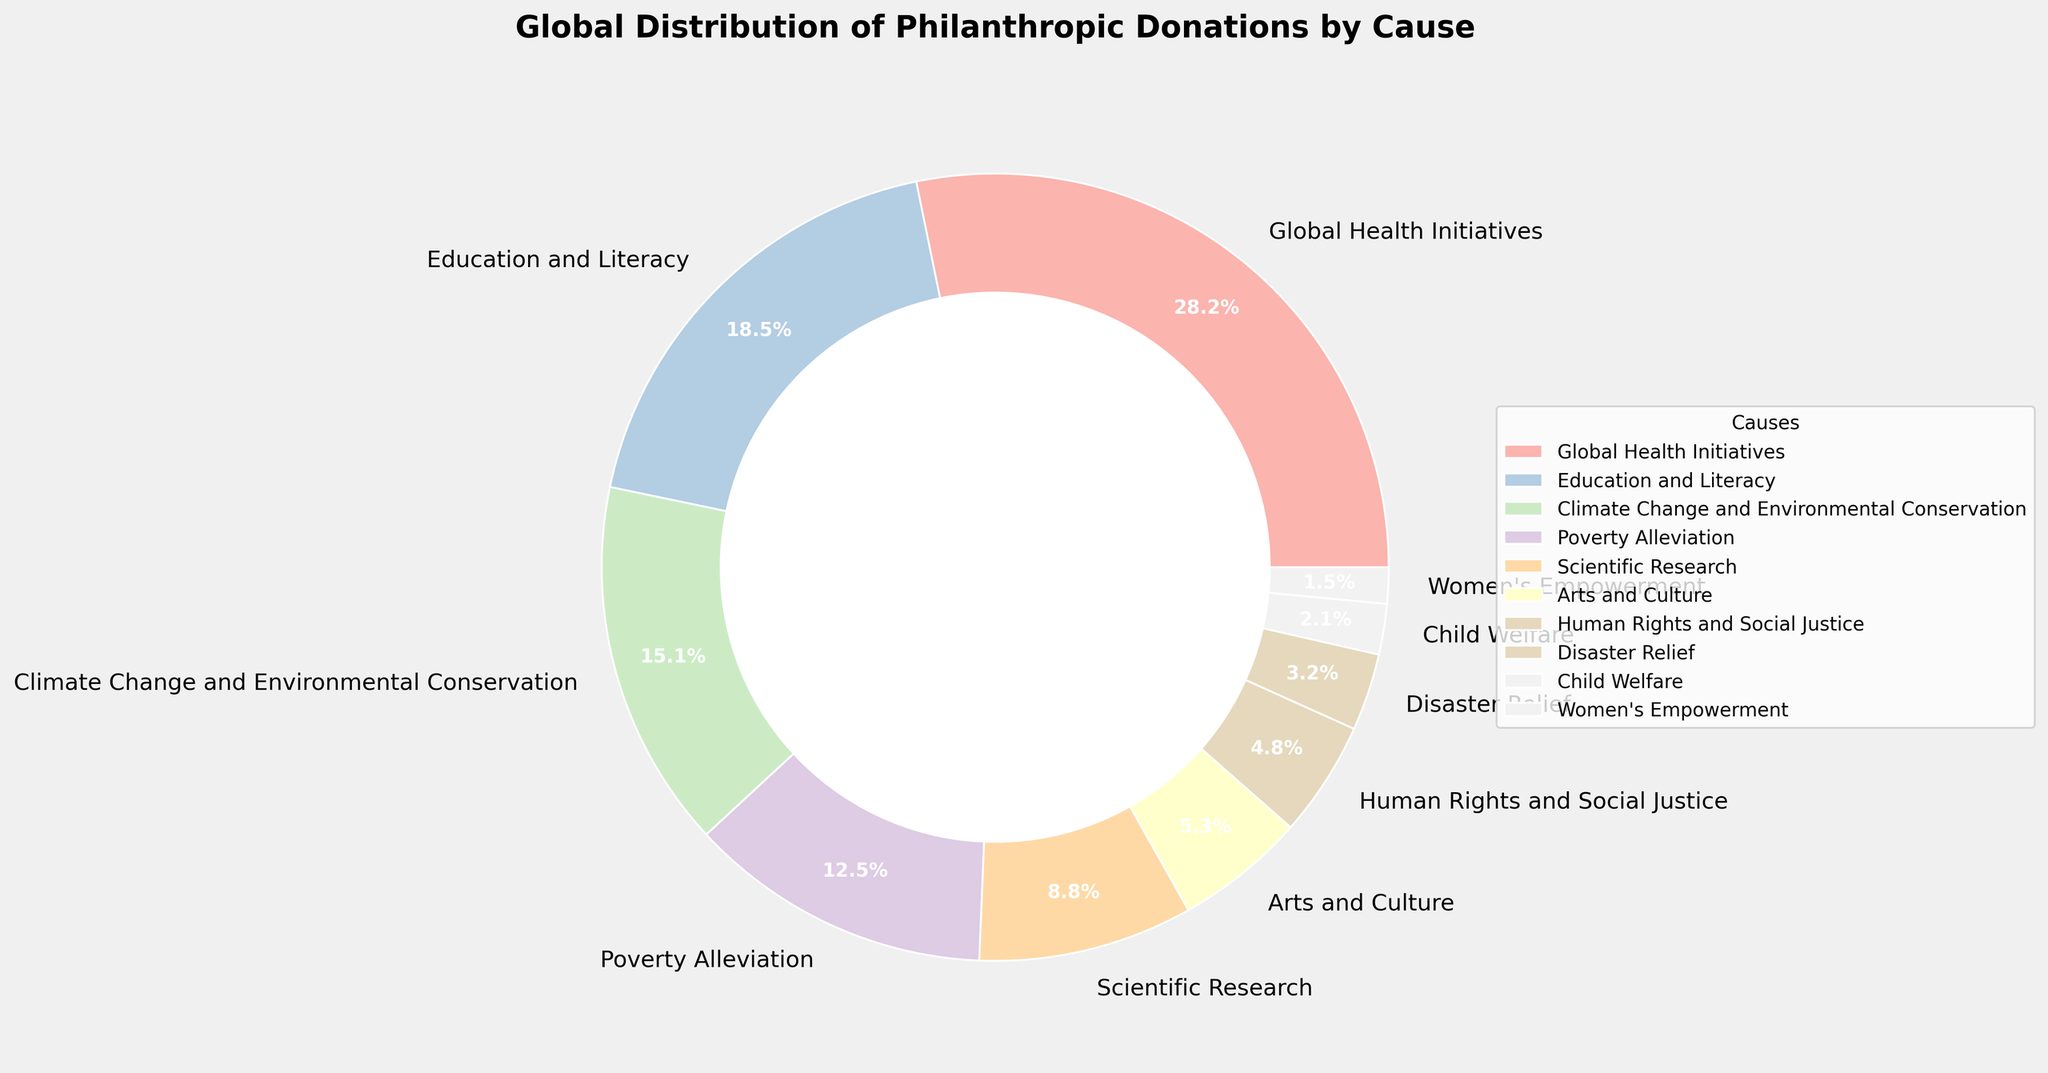What percentage of donations are directed towards Global Health Initiatives? Look at the segment labeled "Global Health Initiatives" in the pie chart and read off its percentage.
Answer: 28.5% Which cause receives the smallest percentage of donations? Identify the smallest segment in the pie chart, which is labeled "Women's Empowerment."
Answer: Women's Empowerment What is the percentage difference between funding for Education and Literacy and Scientific Research? Subtract the percentage of Scientific Research from that of Education and Literacy: 18.7% - 8.9% = 9.8%
Answer: 9.8% How much more funding does Climate Change and Environmental Conservation receive compared to Disaster Relief? Subtract the percentage of Disaster Relief from that of Climate Change and Environmental Conservation: 15.3% - 3.2% = 12.1%
Answer: 12.1% List the causes that comprise more than 15% of the total donations. Identify the segments with percentages greater than 15%. These are "Global Health Initiatives" and "Education and Literacy."
Answer: Global Health Initiatives, Education and Literacy Which cause receives exactly 5.4% of the donations? Find the segment labeled "Arts and Culture" and note its percentage.
Answer: Arts and Culture How many causes receive less than 10% of the total donations? Count the segments with percentages lower than 10%. These are "Scientific Research," "Arts and Culture," "Human Rights and Social Justice," "Disaster Relief," "Child Welfare," and "Women's Empowerment," totaling 6 causes.
Answer: 6 What is the combined percentage of donations for Child Welfare and Women's Empowerment? Add the percentages for Child Welfare and Women's Empowerment: 2.1% + 1.5% = 3.6%
Answer: 3.6% Which cause appears with a green shade in the chart? Refer to the color legend on the pie chart and locate which cause is colored green. Employing a knowledge of pastel palettes, the likely assignment based on conventional color order is "Climate Change and Environmental Conservation."
Answer: Climate Change and Environmental Conservation 